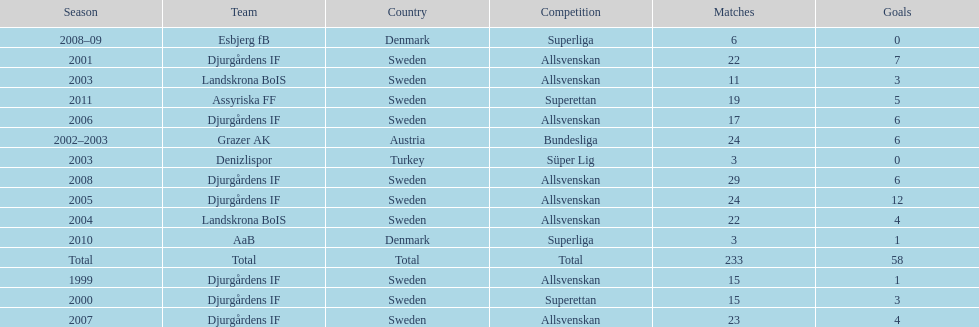How many matches overall were there? 233. 